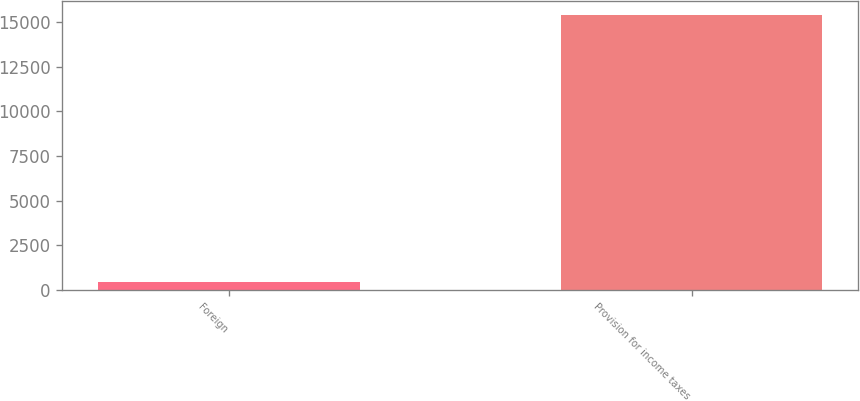<chart> <loc_0><loc_0><loc_500><loc_500><bar_chart><fcel>Foreign<fcel>Provision for income taxes<nl><fcel>438<fcel>15378<nl></chart> 